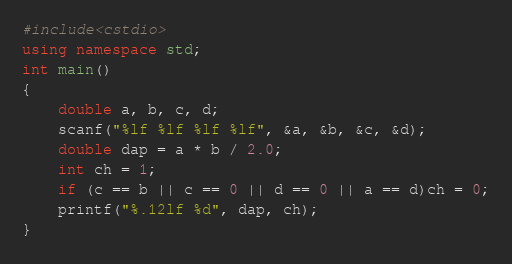<code> <loc_0><loc_0><loc_500><loc_500><_C++_>#include<cstdio>
using namespace std;
int main()
{
	double a, b, c, d;
	scanf("%lf %lf %lf %lf", &a, &b, &c, &d);
	double dap = a * b / 2.0;
	int ch = 1;
	if (c == b || c == 0 || d == 0 || a == d)ch = 0;
	printf("%.12lf %d", dap, ch);
}</code> 